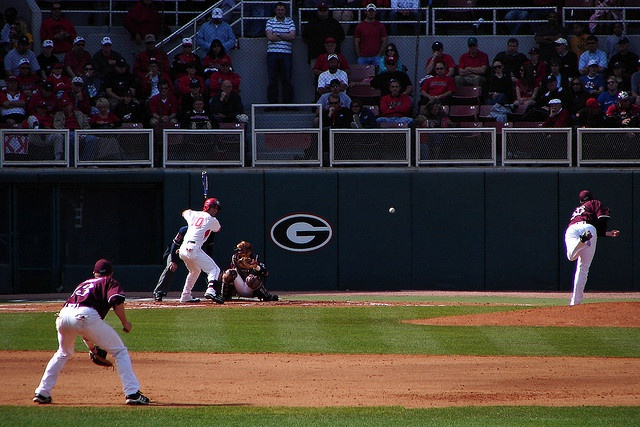Describe the objects in this image and their specific colors. I can see people in black, navy, gray, and brown tones, people in black, white, gray, and darkgray tones, people in black, navy, blue, and gray tones, people in black, maroon, gray, and darkgray tones, and people in black, maroon, navy, and blue tones in this image. 